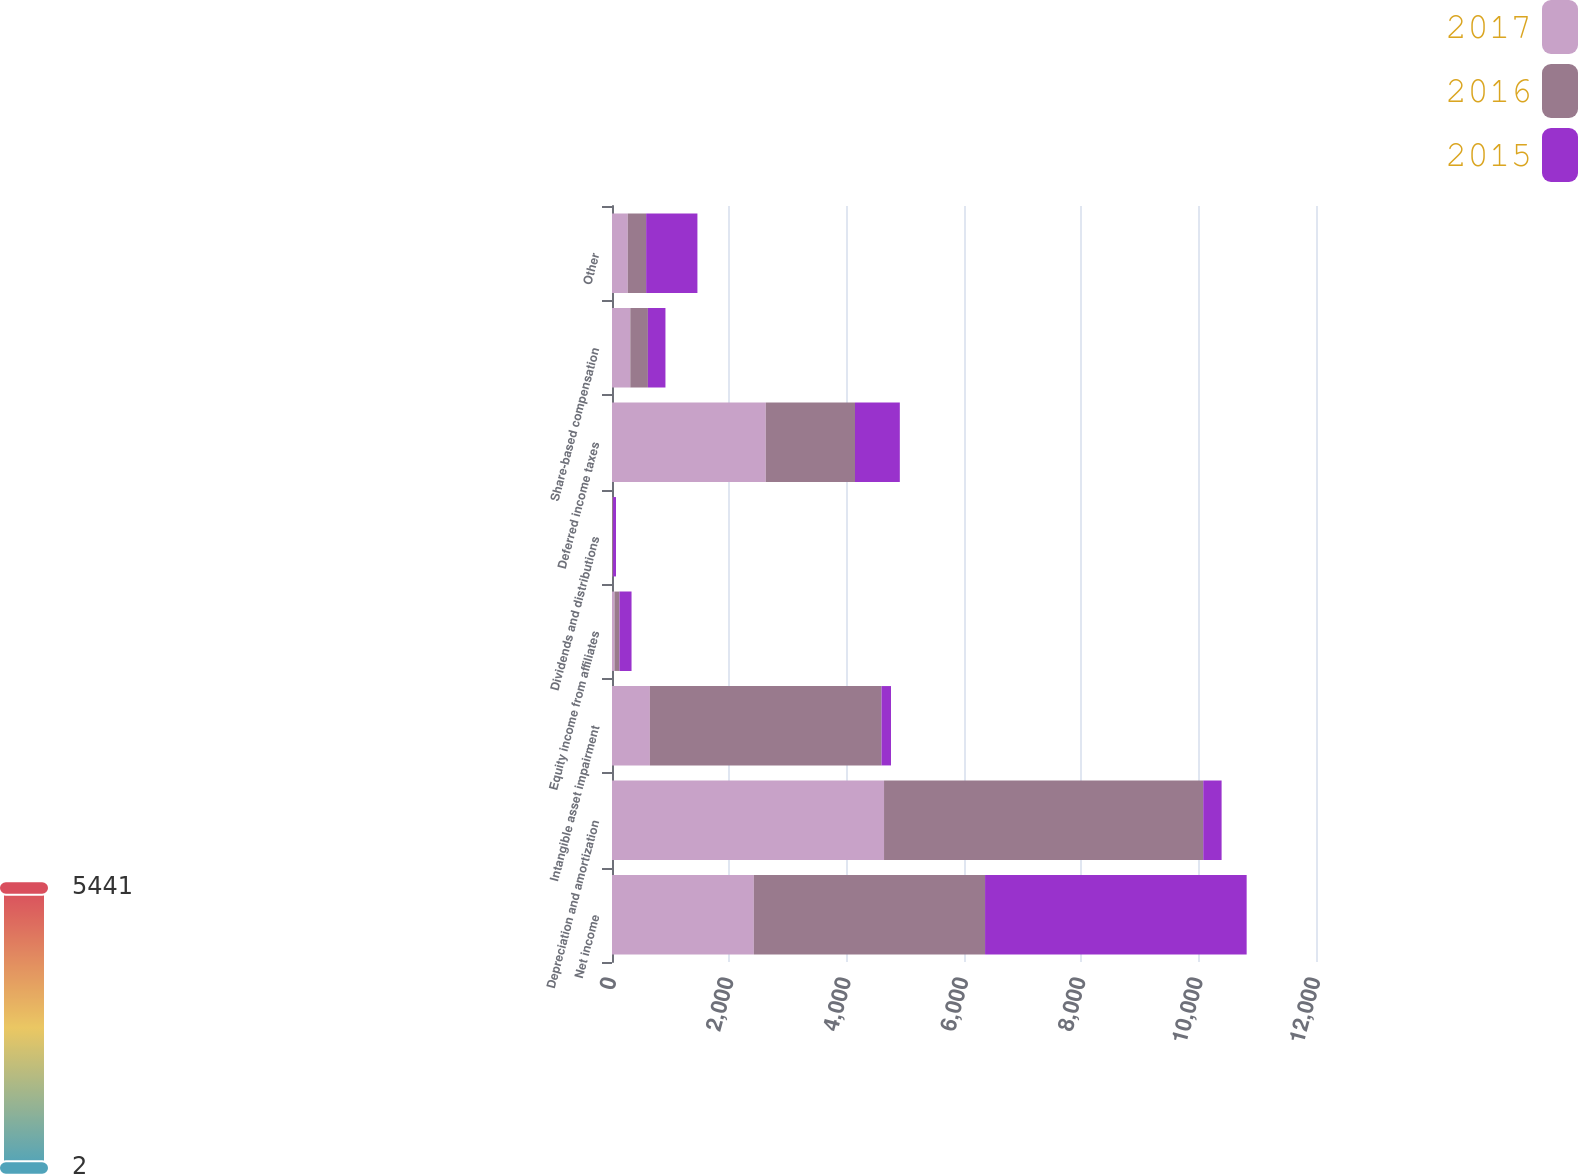Convert chart. <chart><loc_0><loc_0><loc_500><loc_500><stacked_bar_chart><ecel><fcel>Net income<fcel>Depreciation and amortization<fcel>Intangible asset impairment<fcel>Equity income from affiliates<fcel>Dividends and distributions<fcel>Deferred income taxes<fcel>Share-based compensation<fcel>Other<nl><fcel>2017<fcel>2418<fcel>4637<fcel>646<fcel>42<fcel>2<fcel>2621<fcel>312<fcel>269<nl><fcel>2016<fcel>3941<fcel>5441<fcel>3948<fcel>86<fcel>16<fcel>1521<fcel>300<fcel>313<nl><fcel>2015<fcel>4459<fcel>313<fcel>162<fcel>205<fcel>50<fcel>764<fcel>299<fcel>874<nl></chart> 